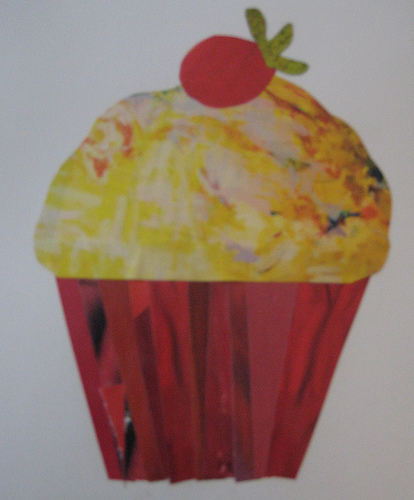<image>
Is there a cherry on the wall? Yes. Looking at the image, I can see the cherry is positioned on top of the wall, with the wall providing support. 